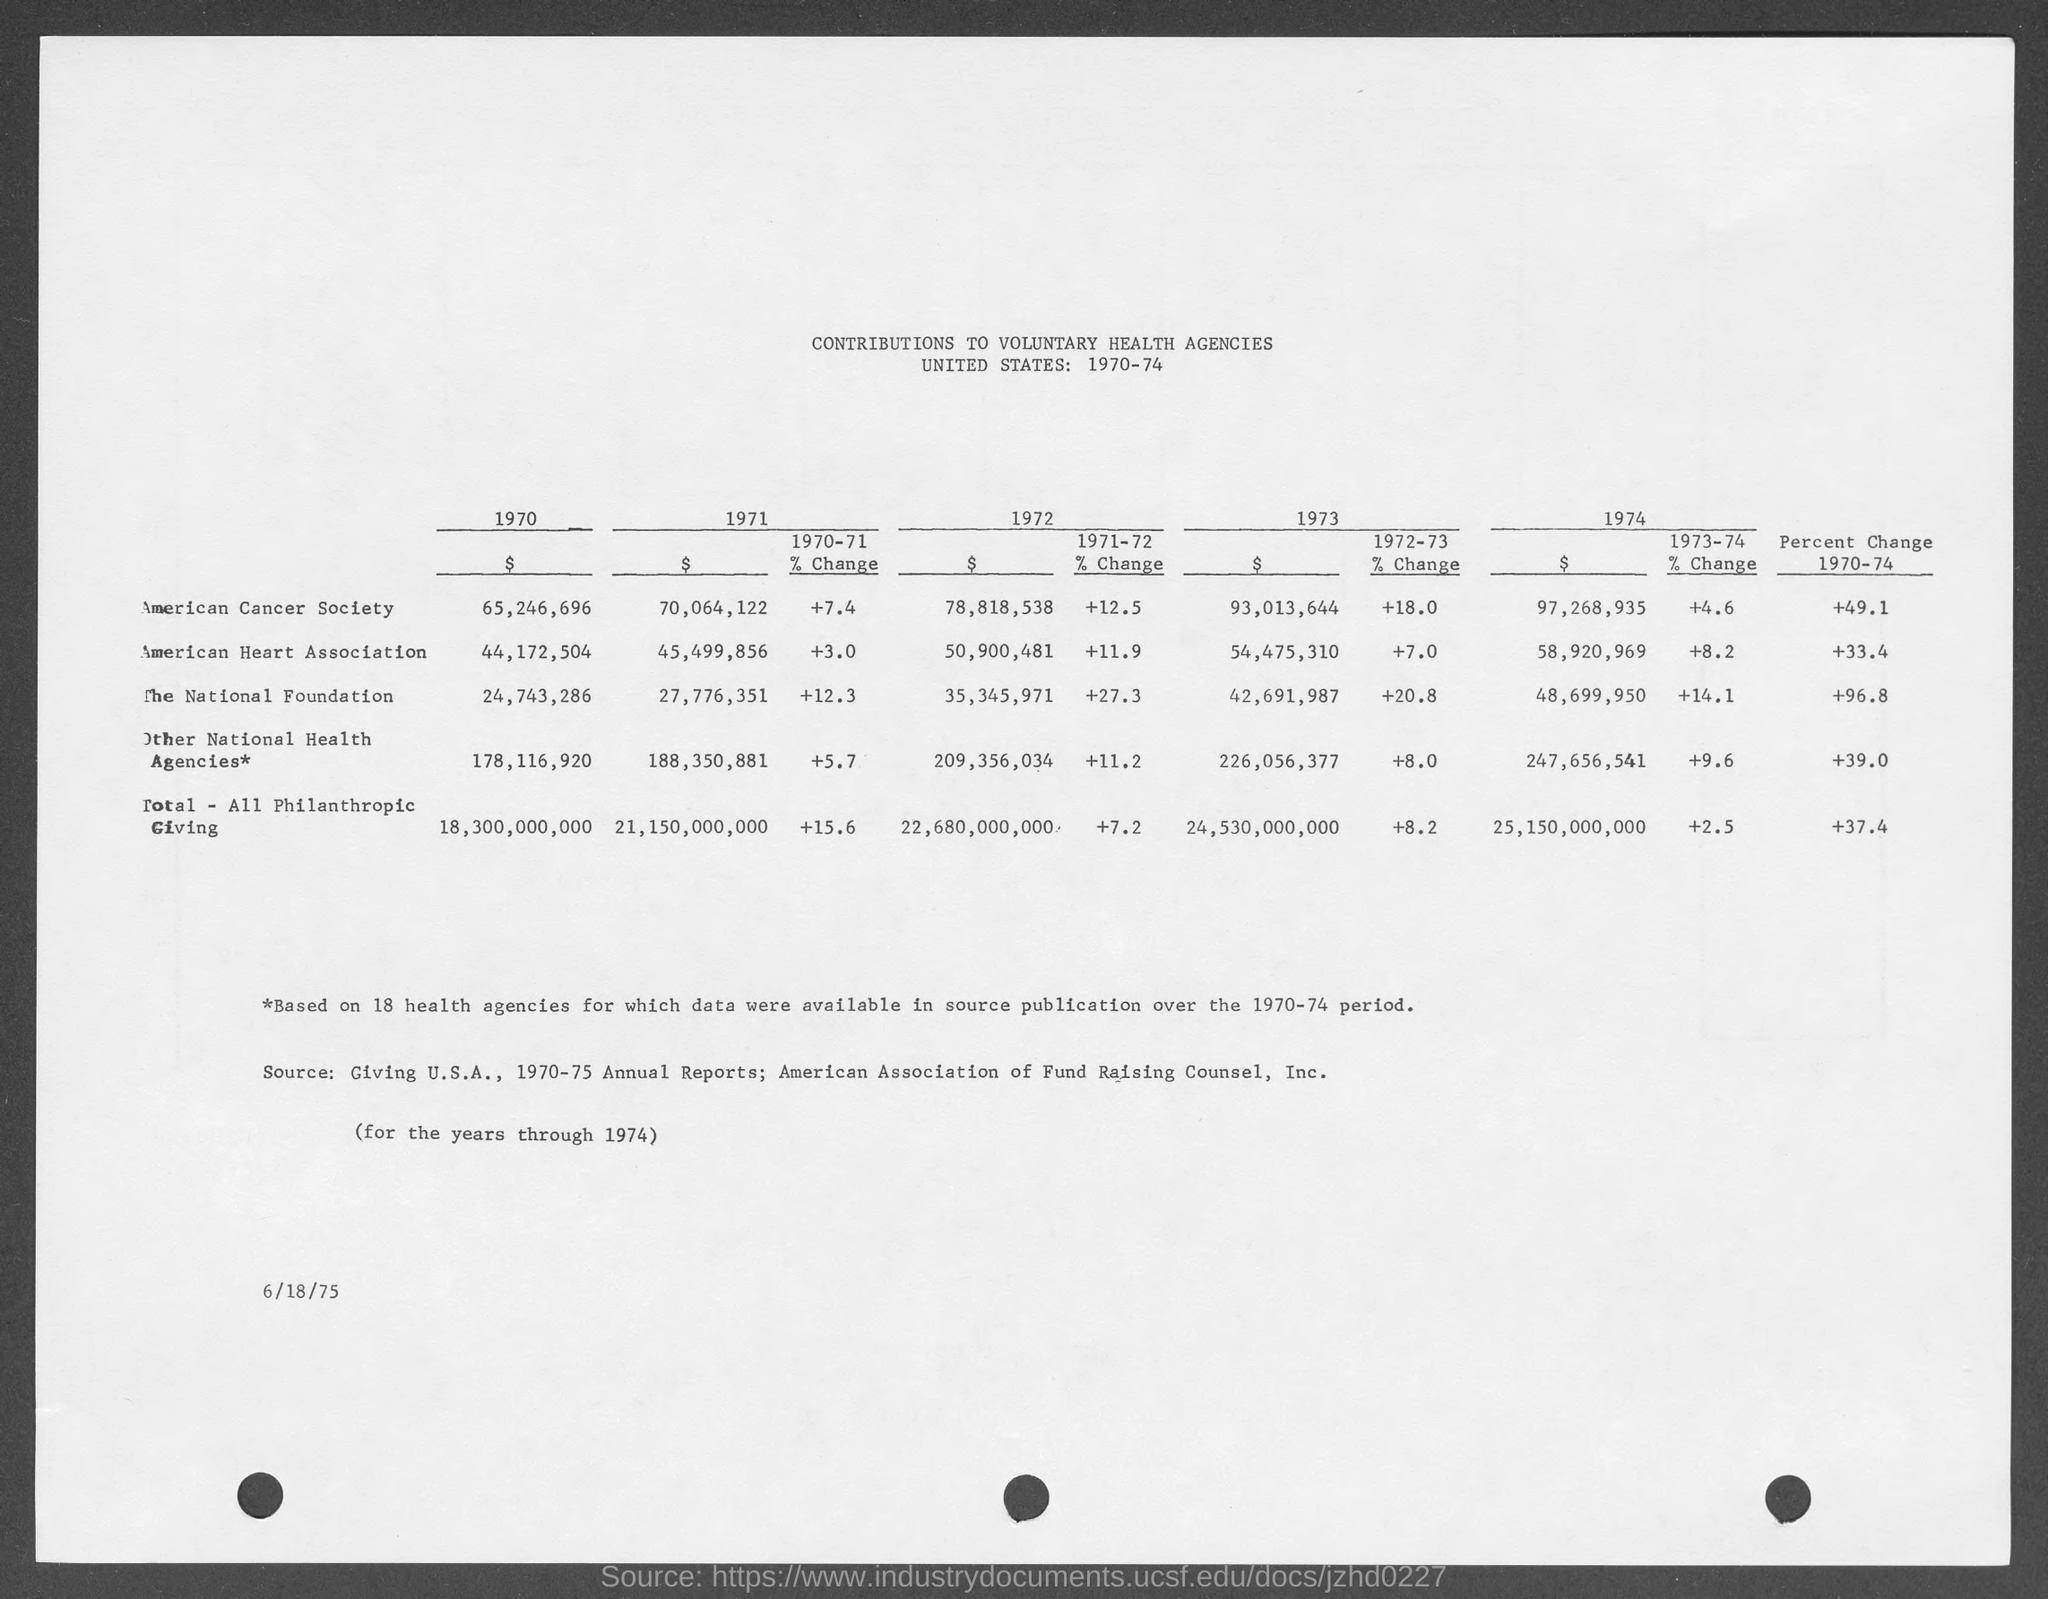Draw attention to some important aspects in this diagram. The American Cancer Society experienced a 4.6% increase in funding during the years 1973-1974. In the year 1971, the American Heart Association received a contribution of $45,499,856. In the year 1970, a contribution of $65,246,696 was given to the American Cancer Society. The amount of the percent change in the national foundation during the year 1971-72 was +27.3%. The percent change in the American Heart Association from 1970-74 was +33.4%. 